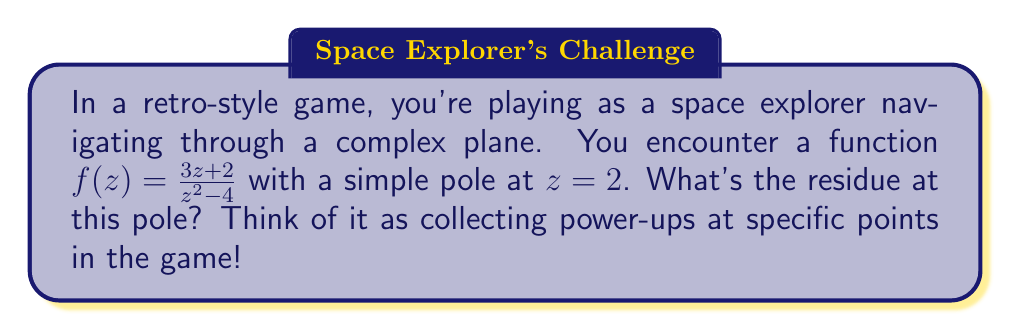Help me with this question. Let's approach this step-by-step:

1) For a simple pole at $z=a$, the residue is given by:

   $$ \text{Res}(f,a) = \lim_{z \to a} (z-a)f(z) $$

2) In our case, $a=2$ and $f(z) = \frac{3z+2}{z^2-4}$

3) Let's substitute these into the formula:

   $$ \text{Res}(f,2) = \lim_{z \to 2} (z-2)\frac{3z+2}{z^2-4} $$

4) We can factor the denominator:

   $$ \text{Res}(f,2) = \lim_{z \to 2} (z-2)\frac{3z+2}{(z+2)(z-2)} $$

5) The $(z-2)$ cancels out:

   $$ \text{Res}(f,2) = \lim_{z \to 2} \frac{3z+2}{z+2} $$

6) Now we can directly substitute $z=2$:

   $$ \text{Res}(f,2) = \frac{3(2)+2}{2+2} = \frac{8}{4} = 2 $$

Therefore, the residue at the simple pole $z=2$ is 2.
Answer: $2$ 